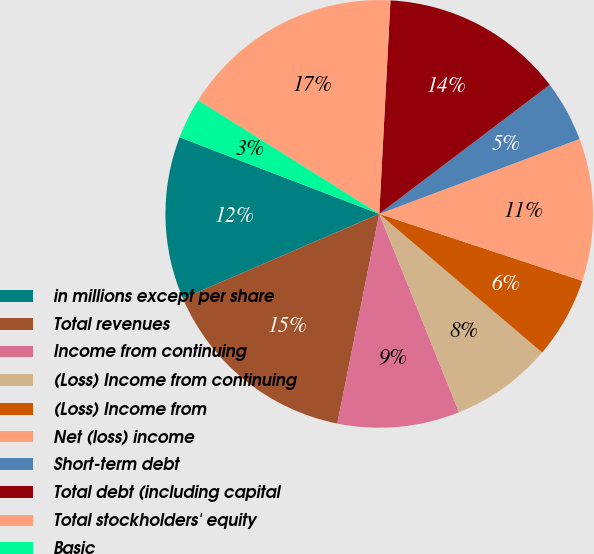Convert chart to OTSL. <chart><loc_0><loc_0><loc_500><loc_500><pie_chart><fcel>in millions except per share<fcel>Total revenues<fcel>Income from continuing<fcel>(Loss) Income from continuing<fcel>(Loss) Income from<fcel>Net (loss) income<fcel>Short-term debt<fcel>Total debt (including capital<fcel>Total stockholders' equity<fcel>Basic<nl><fcel>12.31%<fcel>15.38%<fcel>9.23%<fcel>7.69%<fcel>6.15%<fcel>10.77%<fcel>4.62%<fcel>13.85%<fcel>16.92%<fcel>3.08%<nl></chart> 